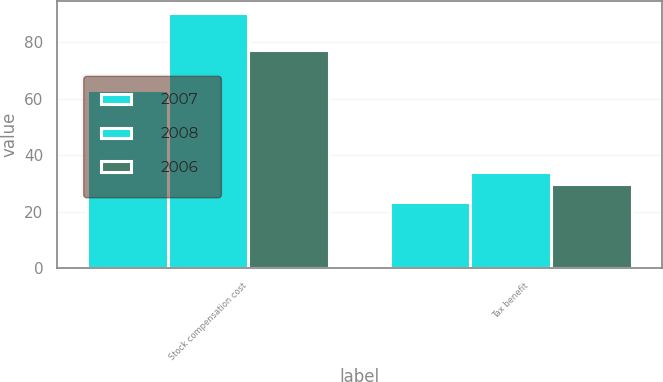Convert chart to OTSL. <chart><loc_0><loc_0><loc_500><loc_500><stacked_bar_chart><ecel><fcel>Stock compensation cost<fcel>Tax benefit<nl><fcel>2007<fcel>63.2<fcel>23.5<nl><fcel>2008<fcel>90.2<fcel>34<nl><fcel>2006<fcel>77.1<fcel>29.7<nl></chart> 